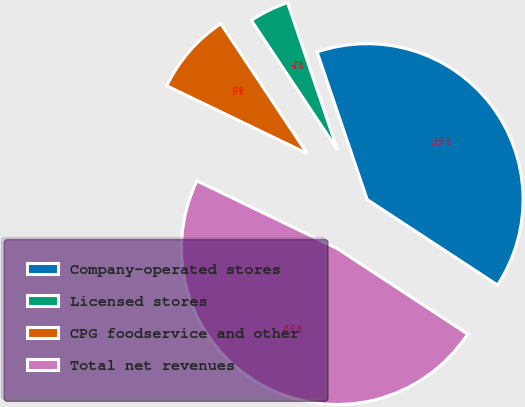Convert chart to OTSL. <chart><loc_0><loc_0><loc_500><loc_500><pie_chart><fcel>Company-operated stores<fcel>Licensed stores<fcel>CPG foodservice and other<fcel>Total net revenues<nl><fcel>39.45%<fcel>4.13%<fcel>8.51%<fcel>47.92%<nl></chart> 